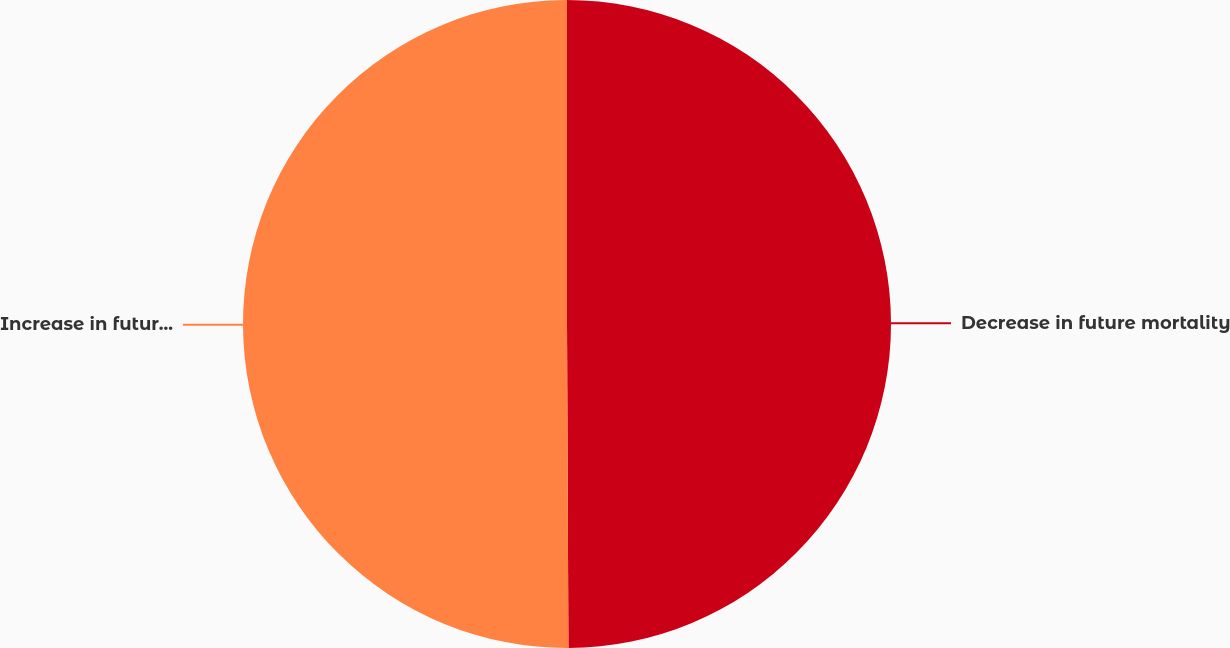Convert chart to OTSL. <chart><loc_0><loc_0><loc_500><loc_500><pie_chart><fcel>Decrease in future mortality<fcel>Increase in future mortality<nl><fcel>49.93%<fcel>50.07%<nl></chart> 